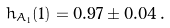Convert formula to latex. <formula><loc_0><loc_0><loc_500><loc_500>h _ { A _ { 1 } } ( 1 ) = 0 . 9 7 \pm 0 . 0 4 \, .</formula> 